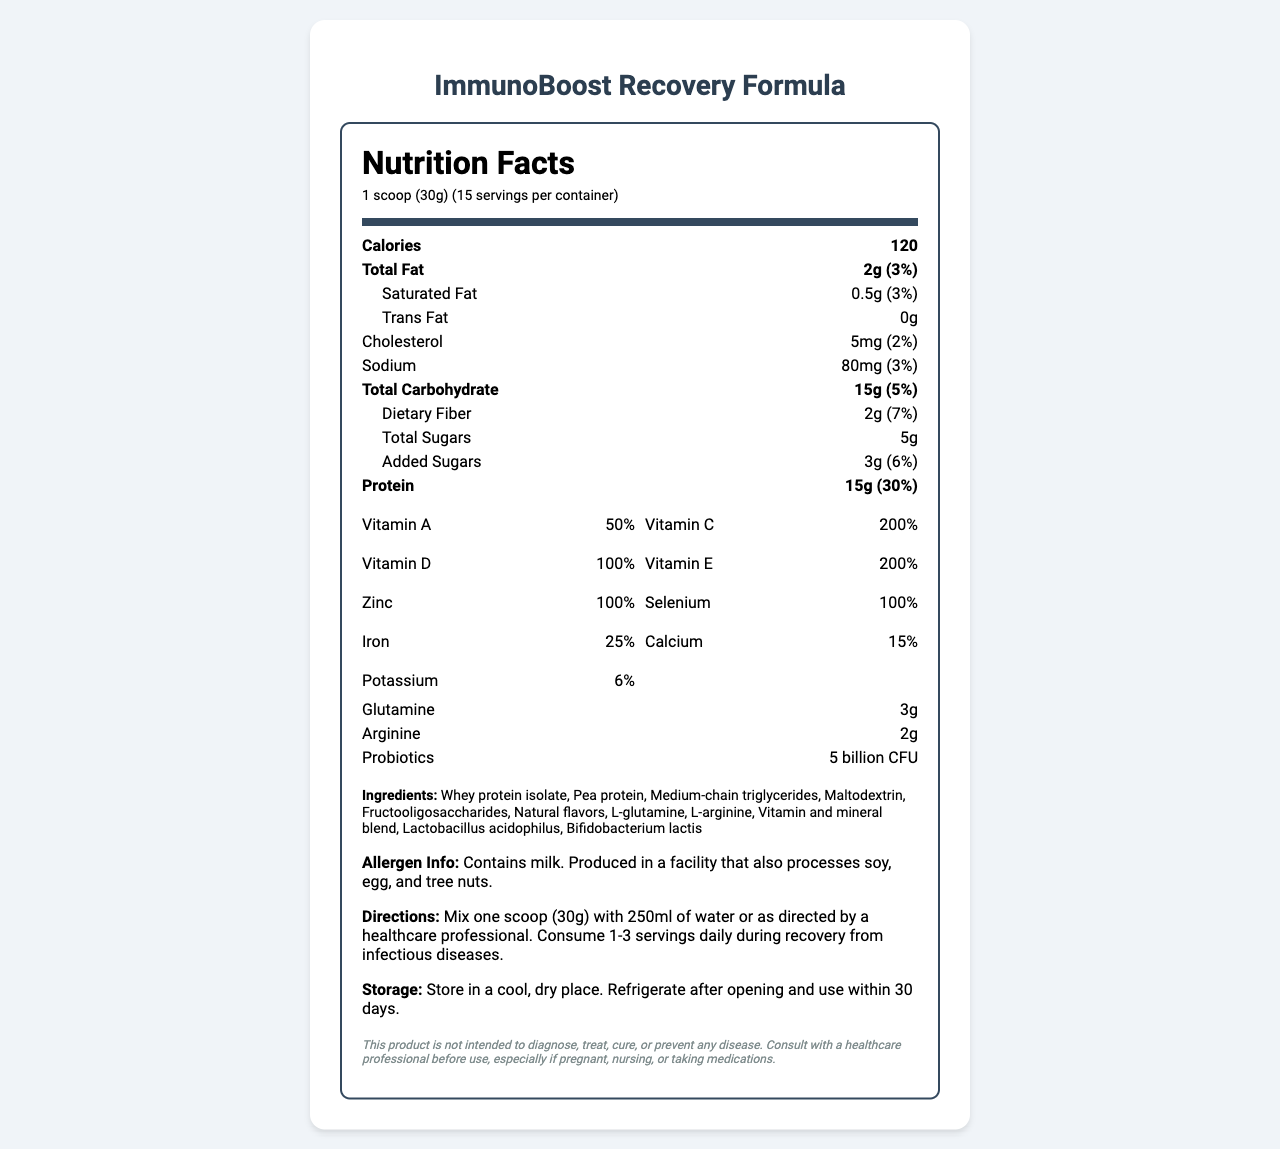what is the serving size of the ImmunoBoost Recovery Formula? The serving size is mentioned at the beginning of the Nutrition Facts Label as "1 scoop (30g)".
Answer: 1 scoop (30g) how many servings are there per container? The document states "15 servings per container" next to the serving size information.
Answer: 15 what is the amount of protein per serving, and what is its daily value percentage? The Nutrition Facts Label shows "Protein: 15g (30%)" under the protein section.
Answer: 15g, 30% name at least three key ingredients in the ImmunoBoost Recovery Formula. The ingredients list includes "Whey protein isolate, Pea protein, Medium-chain triglycerides..."
Answer: Whey protein isolate, Pea protein, Medium-chain triglycerides how much Vitamin C is in a serving and its daily value percentage? The Vitamin C content is listed as "180mg (200%)".
Answer: 180mg, 200% what is the daily value percentage of vitamin D in the formula? The document lists the vitamin D daily value as "100%".
Answer: 100% which of the following vitamins has the highest daily value percentage? A. Vitamin A B. Vitamin C C. Vitamin D D. Vitamin E Vitamin C has a daily value of 200%, the highest among the options provided.
Answer: B how many grams of dietary fiber are in a serving? A. 1g B. 2g C. 3g D. 4g The document lists "Dietary Fiber: 2g (7%)".
Answer: B is there any trans fat in the ImmunoBoost Recovery Formula? The Nutrition Facts label specifies "Trans Fat: 0g".
Answer: No does the ImmunoBoost Recovery Formula contain any added sugars? The label states "Added Sugars: 3g (6%)".
Answer: Yes summarize the main idea of the ImmunoBoost Recovery Formula's nutrition label. The document details the nutritional content, including macro and micronutrients, additional beneficial ingredients, directions for use, storage information, and a disclaimer.
Answer: The ImmunoBoost Recovery Formula provides a balanced nutritional supplement designed for recovery in patients with infectious diseases. It contains vital macronutrients, high levels of vitamins and minerals, and additional beneficial ingredients like probiotics, glutamine, and arginine. The product is intended to support immune function and overall recovery. state the directions for using the ImmunoBoost Recovery Formula. The directions are listed under the "Directions" section in the label.
Answer: Mix one scoop (30g) with 250ml of water or as directed by a healthcare professional. Consume 1-3 servings daily during recovery from infectious diseases. what type of facility is the ImmunoBoost Recovery Formula produced in? The allergen information states it is "Produced in a facility that also processes soy, egg, and tree nuts."
Answer: Facility that also processes soy, egg, and tree nuts. explain why it is important to store the ImmunoBoost Recovery Formula properly. The document provides storage instructions to maintain product quality and effectiveness.
Answer: Storing the product in a cool, dry place and refrigerating after opening ensures the product's efficacy and safety, and prevents spoilage within the recommended 30 days. what is the intended use of this product? The document mentions it is for use "during recovery from infectious diseases."
Answer: To support recovery in patients with infectious diseases. can the ImmunoBoost Recovery Formula cure diseases? The disclaimer explicitly states, "This product is not intended to diagnose, treat, cure, or prevent any disease."
Answer: No what is the customer satisfaction rating of the ImmunoBoost Recovery Formula? The document does not provide any information about customer satisfaction ratings.
Answer: Cannot be determined 